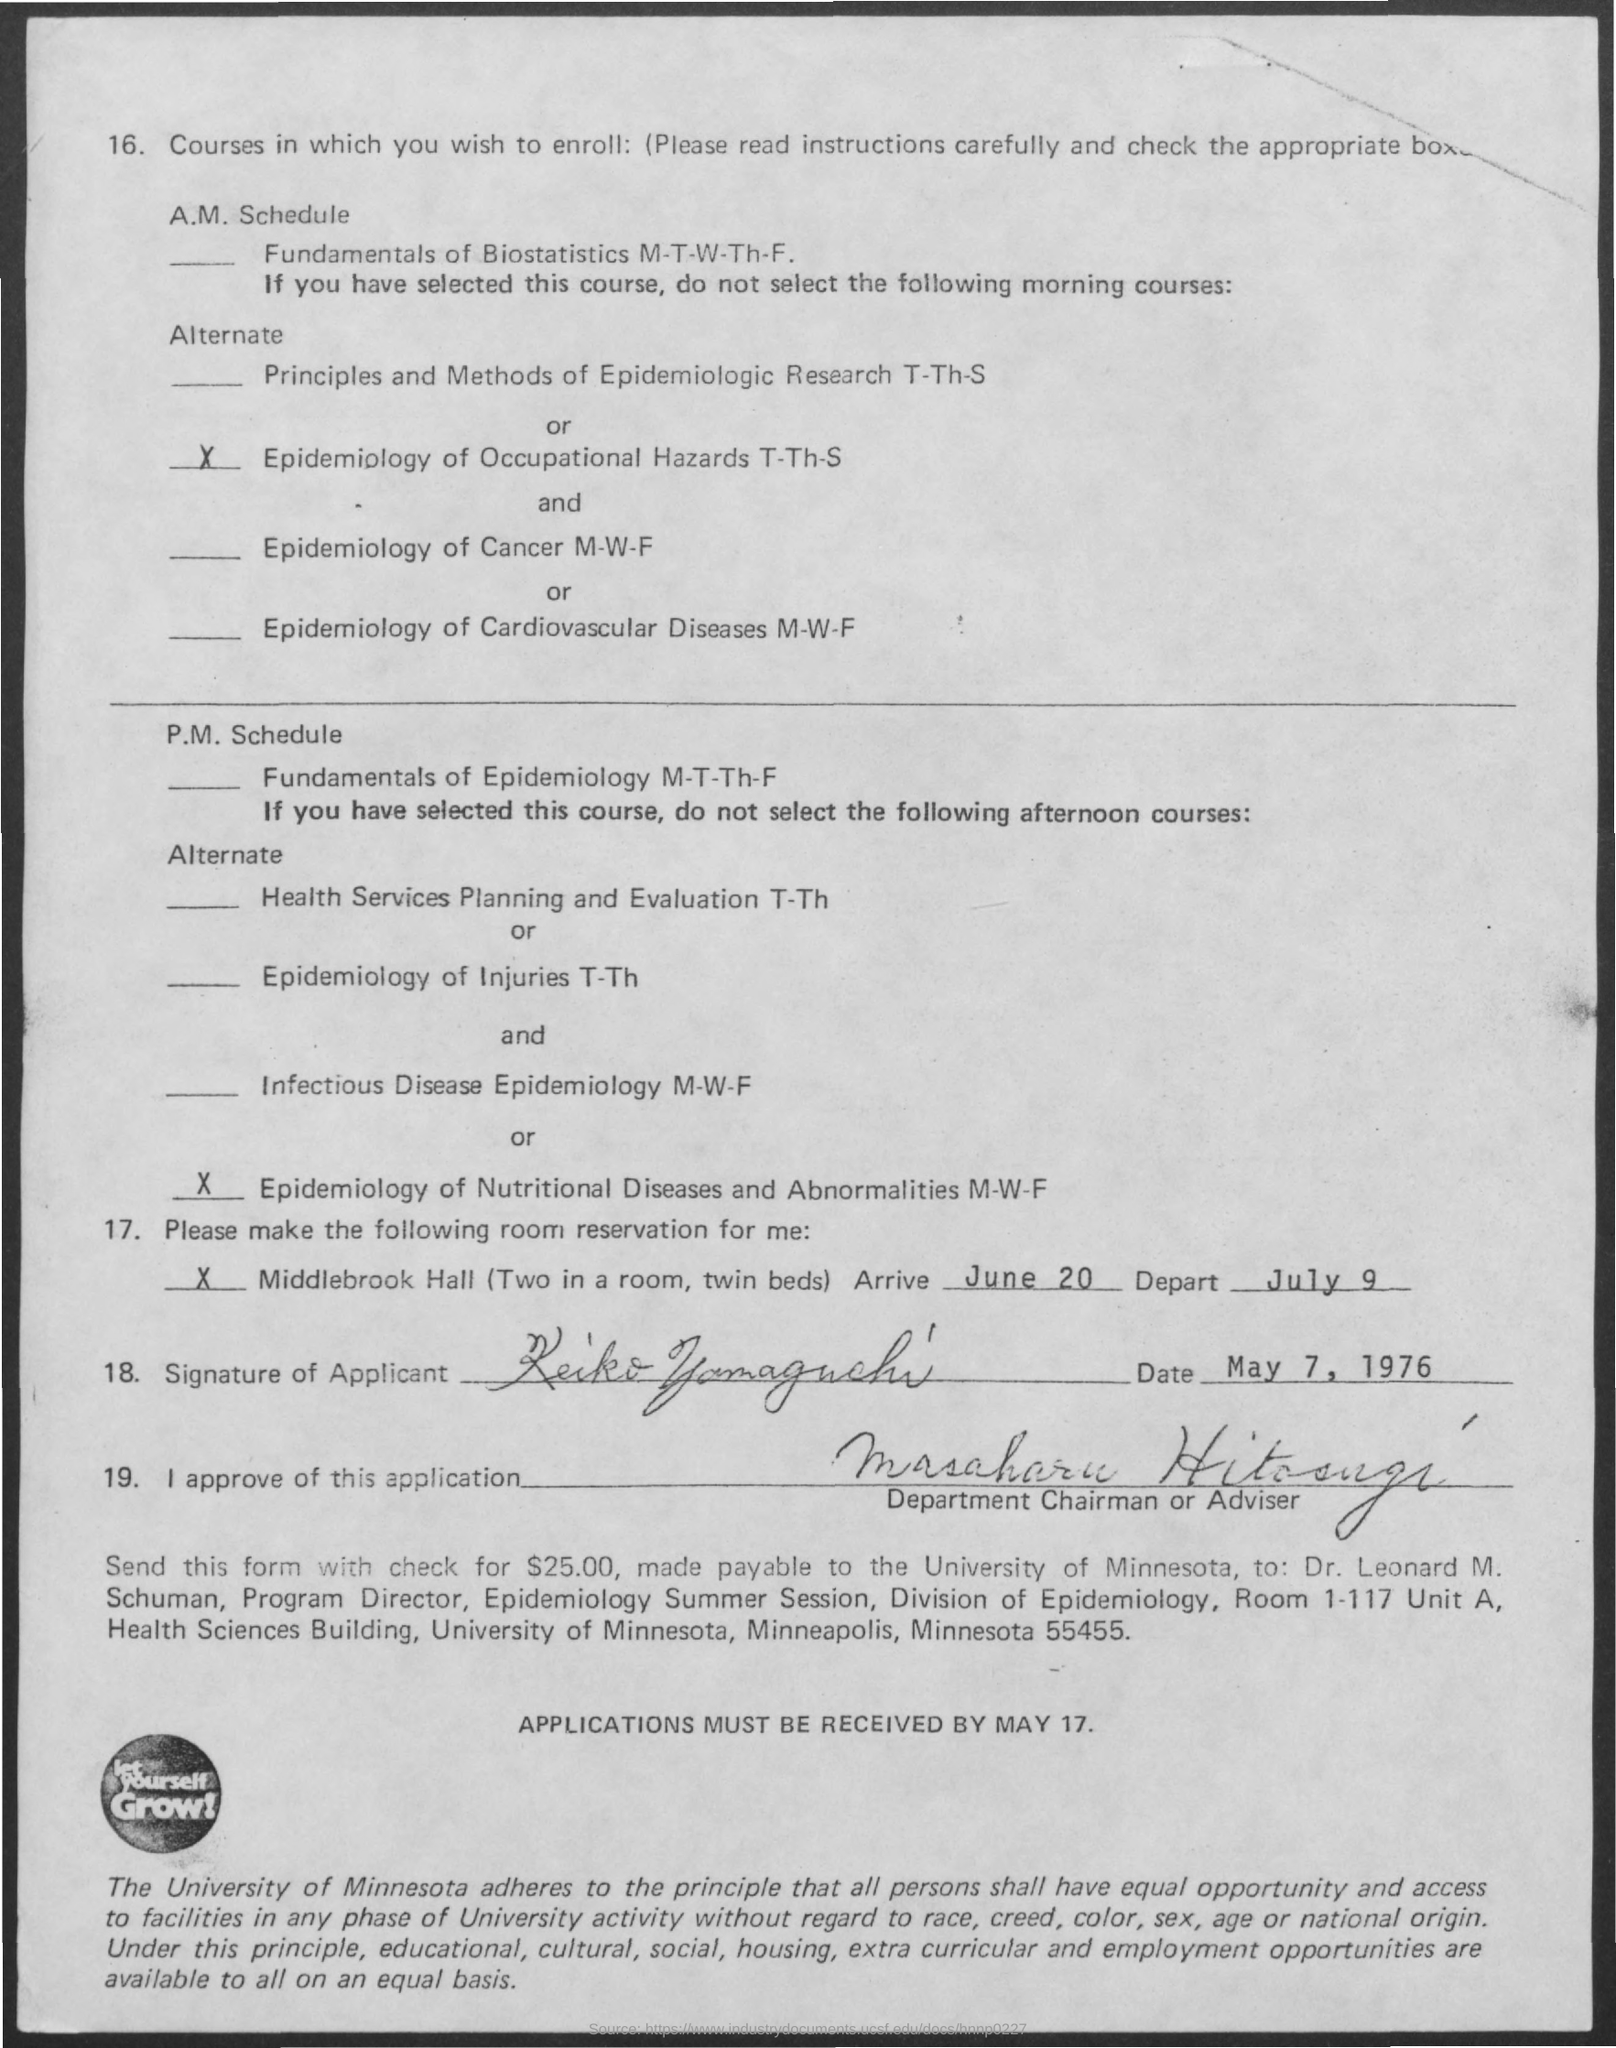Identify some key points in this picture. The departing date is July 9. I, [your name], declare that I will let myself grow by embracing new experiences and opportunities for personal development. The date on which this document was signed is May 7, 1976. The arrival date is June 20th. 